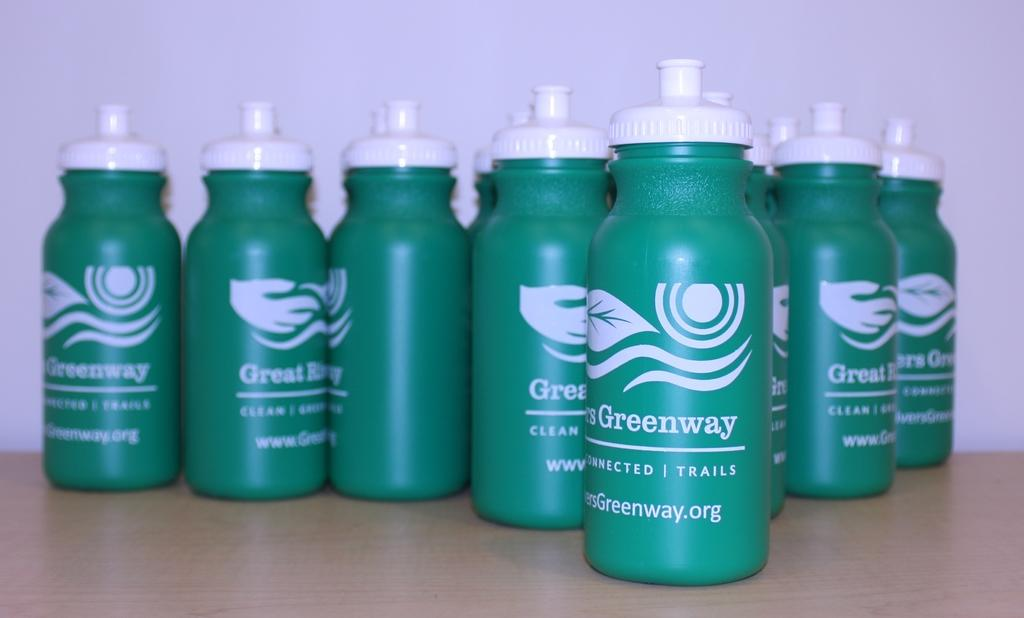<image>
Give a short and clear explanation of the subsequent image. Several bottle of green and white GreatGreenway water bottles. 